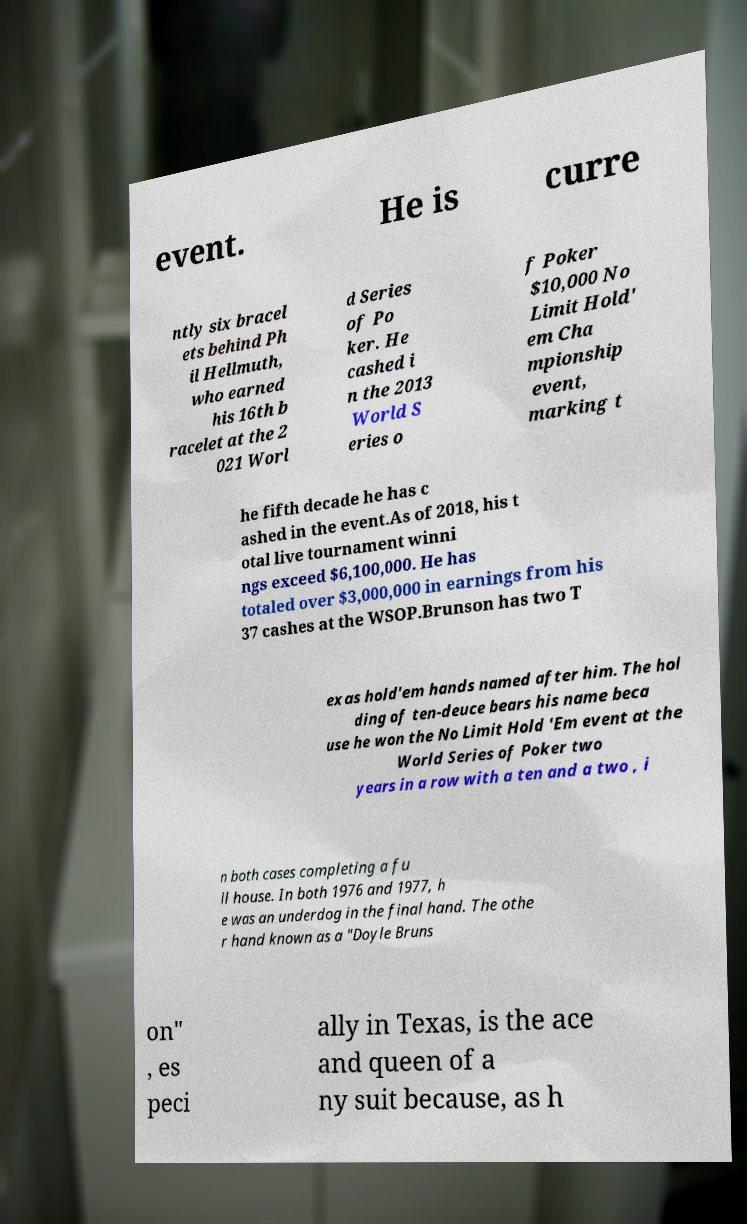What messages or text are displayed in this image? I need them in a readable, typed format. event. He is curre ntly six bracel ets behind Ph il Hellmuth, who earned his 16th b racelet at the 2 021 Worl d Series of Po ker. He cashed i n the 2013 World S eries o f Poker $10,000 No Limit Hold' em Cha mpionship event, marking t he fifth decade he has c ashed in the event.As of 2018, his t otal live tournament winni ngs exceed $6,100,000. He has totaled over $3,000,000 in earnings from his 37 cashes at the WSOP.Brunson has two T exas hold'em hands named after him. The hol ding of ten-deuce bears his name beca use he won the No Limit Hold 'Em event at the World Series of Poker two years in a row with a ten and a two , i n both cases completing a fu ll house. In both 1976 and 1977, h e was an underdog in the final hand. The othe r hand known as a "Doyle Bruns on" , es peci ally in Texas, is the ace and queen of a ny suit because, as h 